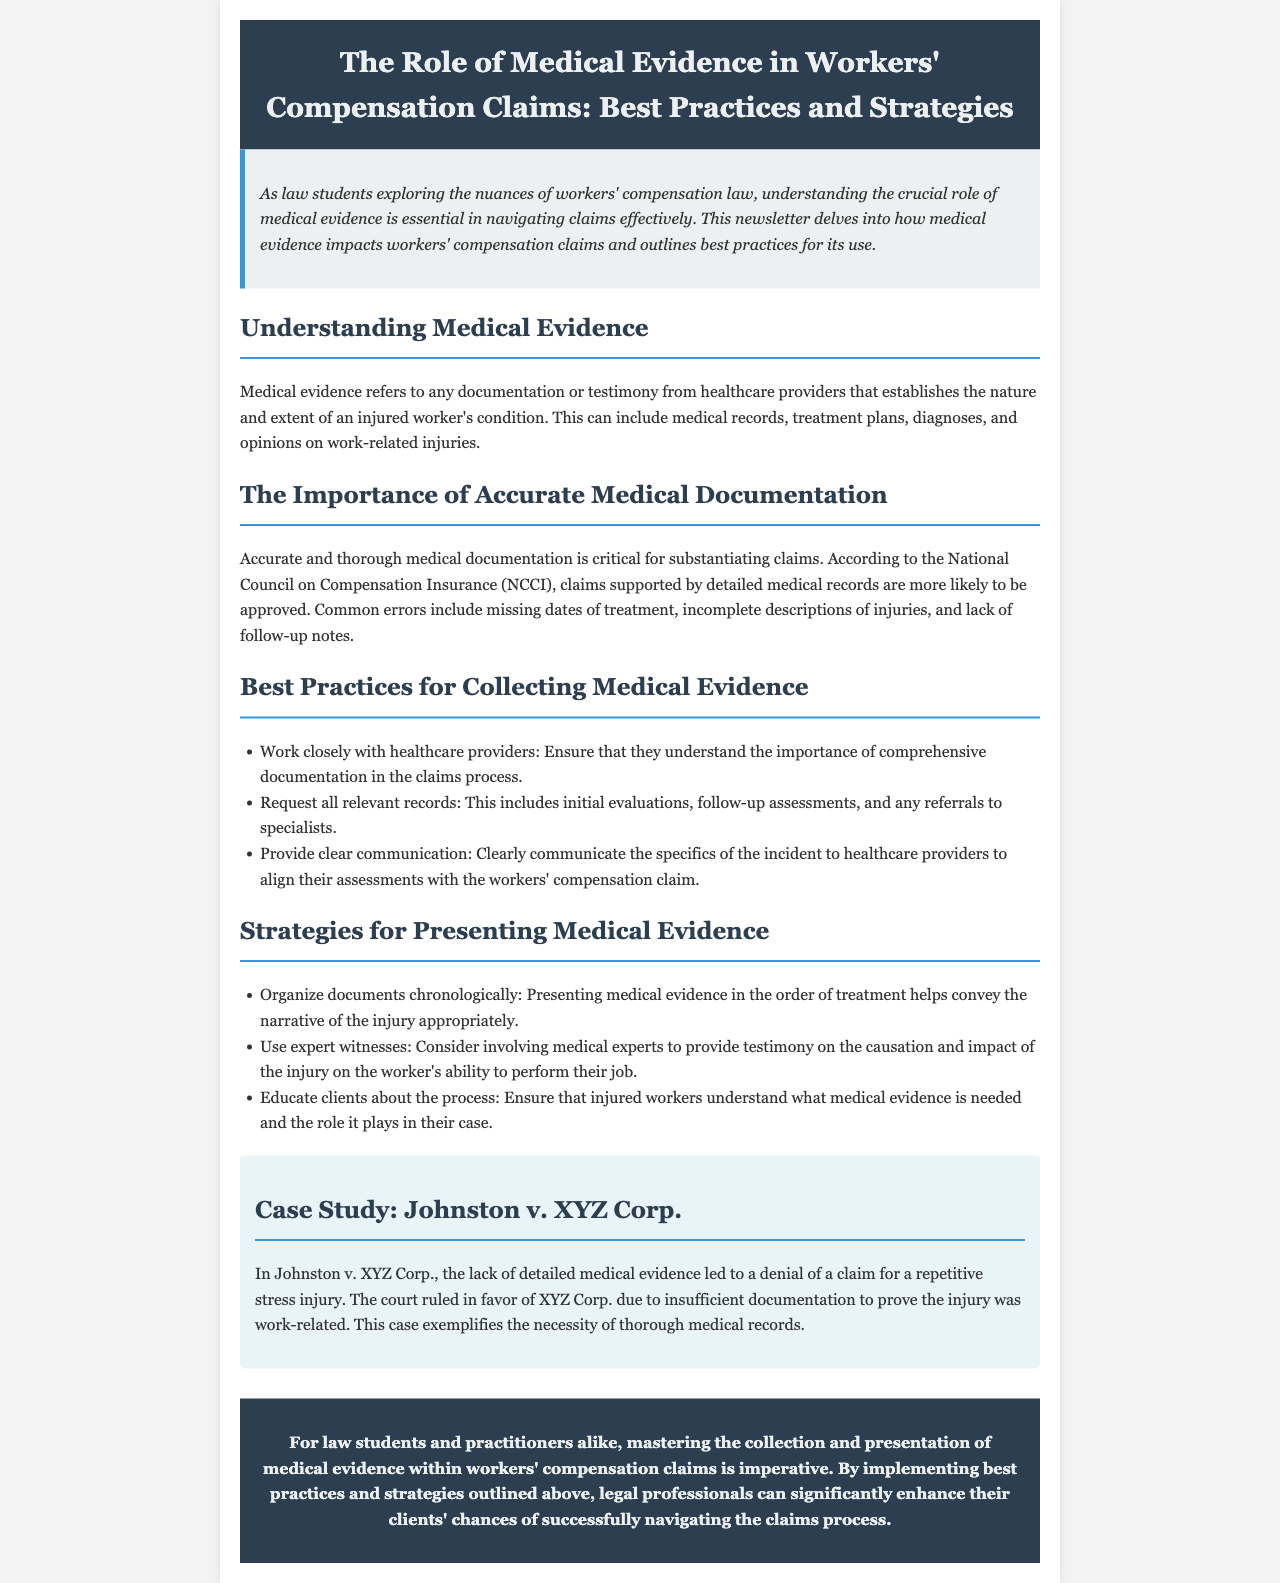What is the main topic of the newsletter? The main topic is the role of medical evidence in workers' compensation claims.
Answer: The role of medical evidence in workers' compensation claims Which organization's statistics are mentioned regarding medical documentation? The newsletter references the National Council on Compensation Insurance (NCCI) for statistics related to medical documentation in claims.
Answer: National Council on Compensation Insurance (NCCI) What is a common error in medical documentation according to the newsletter? The newsletter lists several common errors in medical documentation, one of which is missing dates of treatment.
Answer: Missing dates of treatment What is one best practice for collecting medical evidence? The newsletter outlines several best practices, one being to work closely with healthcare providers.
Answer: Work closely with healthcare providers In the case study, what was the reason for the denial of the claim in Johnston v. XYZ Corp.? The denial of the claim was due to a lack of detailed medical evidence.
Answer: Lack of detailed medical evidence What kind of witnesses does the newsletter suggest using when presenting medical evidence? It suggests involving medical experts as witnesses to provide testimony.
Answer: Medical experts What does the newsletter highlight as essential for law students in workers' compensation cases? The newsletter emphasizes the importance of mastering the collection and presentation of medical evidence.
Answer: Mastering the collection and presentation of medical evidence What should be done to help injured workers understand the claims process? It is important to educate clients about the process regarding the necessary medical evidence.
Answer: Educate clients about the process 